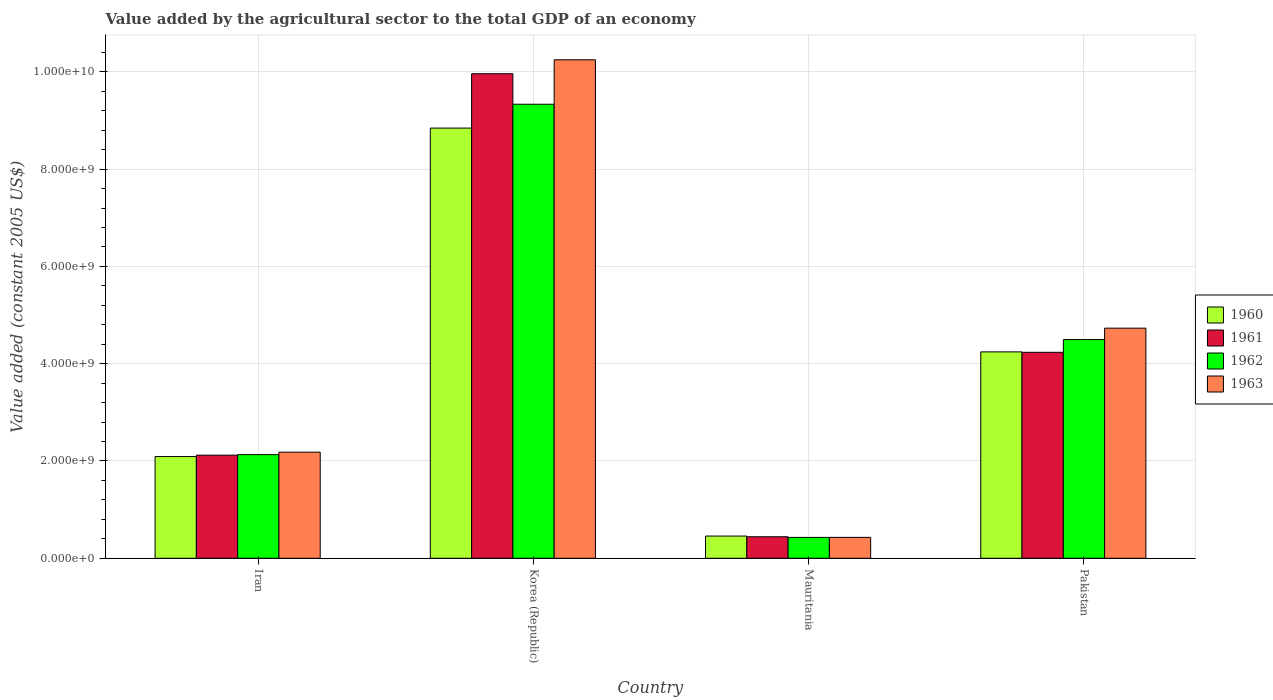How many different coloured bars are there?
Offer a very short reply. 4. Are the number of bars on each tick of the X-axis equal?
Provide a short and direct response. Yes. How many bars are there on the 3rd tick from the right?
Your answer should be compact. 4. What is the label of the 3rd group of bars from the left?
Your answer should be very brief. Mauritania. In how many cases, is the number of bars for a given country not equal to the number of legend labels?
Keep it short and to the point. 0. What is the value added by the agricultural sector in 1960 in Pakistan?
Make the answer very short. 4.24e+09. Across all countries, what is the maximum value added by the agricultural sector in 1960?
Your answer should be compact. 8.84e+09. Across all countries, what is the minimum value added by the agricultural sector in 1962?
Give a very brief answer. 4.29e+08. In which country was the value added by the agricultural sector in 1962 minimum?
Ensure brevity in your answer.  Mauritania. What is the total value added by the agricultural sector in 1963 in the graph?
Your answer should be very brief. 1.76e+1. What is the difference between the value added by the agricultural sector in 1963 in Iran and that in Pakistan?
Offer a very short reply. -2.55e+09. What is the difference between the value added by the agricultural sector in 1960 in Korea (Republic) and the value added by the agricultural sector in 1963 in Pakistan?
Make the answer very short. 4.11e+09. What is the average value added by the agricultural sector in 1962 per country?
Offer a terse response. 4.10e+09. What is the difference between the value added by the agricultural sector of/in 1960 and value added by the agricultural sector of/in 1961 in Mauritania?
Provide a short and direct response. 1.44e+07. In how many countries, is the value added by the agricultural sector in 1961 greater than 2400000000 US$?
Keep it short and to the point. 2. What is the ratio of the value added by the agricultural sector in 1963 in Iran to that in Pakistan?
Offer a terse response. 0.46. What is the difference between the highest and the second highest value added by the agricultural sector in 1961?
Your answer should be very brief. -7.84e+09. What is the difference between the highest and the lowest value added by the agricultural sector in 1963?
Your answer should be very brief. 9.82e+09. Is it the case that in every country, the sum of the value added by the agricultural sector in 1961 and value added by the agricultural sector in 1962 is greater than the sum of value added by the agricultural sector in 1960 and value added by the agricultural sector in 1963?
Make the answer very short. No. What does the 3rd bar from the left in Korea (Republic) represents?
Offer a very short reply. 1962. How many bars are there?
Keep it short and to the point. 16. What is the difference between two consecutive major ticks on the Y-axis?
Your response must be concise. 2.00e+09. Does the graph contain any zero values?
Your answer should be compact. No. Does the graph contain grids?
Ensure brevity in your answer.  Yes. Where does the legend appear in the graph?
Your answer should be compact. Center right. How are the legend labels stacked?
Your response must be concise. Vertical. What is the title of the graph?
Offer a terse response. Value added by the agricultural sector to the total GDP of an economy. Does "2010" appear as one of the legend labels in the graph?
Provide a succinct answer. No. What is the label or title of the Y-axis?
Offer a very short reply. Value added (constant 2005 US$). What is the Value added (constant 2005 US$) of 1960 in Iran?
Ensure brevity in your answer.  2.09e+09. What is the Value added (constant 2005 US$) in 1961 in Iran?
Give a very brief answer. 2.12e+09. What is the Value added (constant 2005 US$) of 1962 in Iran?
Offer a very short reply. 2.13e+09. What is the Value added (constant 2005 US$) in 1963 in Iran?
Keep it short and to the point. 2.18e+09. What is the Value added (constant 2005 US$) of 1960 in Korea (Republic)?
Offer a very short reply. 8.84e+09. What is the Value added (constant 2005 US$) in 1961 in Korea (Republic)?
Your response must be concise. 9.96e+09. What is the Value added (constant 2005 US$) of 1962 in Korea (Republic)?
Your answer should be very brief. 9.33e+09. What is the Value added (constant 2005 US$) in 1963 in Korea (Republic)?
Offer a terse response. 1.02e+1. What is the Value added (constant 2005 US$) of 1960 in Mauritania?
Your answer should be compact. 4.57e+08. What is the Value added (constant 2005 US$) in 1961 in Mauritania?
Provide a succinct answer. 4.42e+08. What is the Value added (constant 2005 US$) in 1962 in Mauritania?
Give a very brief answer. 4.29e+08. What is the Value added (constant 2005 US$) of 1963 in Mauritania?
Keep it short and to the point. 4.30e+08. What is the Value added (constant 2005 US$) of 1960 in Pakistan?
Offer a very short reply. 4.24e+09. What is the Value added (constant 2005 US$) in 1961 in Pakistan?
Make the answer very short. 4.23e+09. What is the Value added (constant 2005 US$) in 1962 in Pakistan?
Keep it short and to the point. 4.50e+09. What is the Value added (constant 2005 US$) in 1963 in Pakistan?
Offer a terse response. 4.73e+09. Across all countries, what is the maximum Value added (constant 2005 US$) in 1960?
Keep it short and to the point. 8.84e+09. Across all countries, what is the maximum Value added (constant 2005 US$) of 1961?
Your answer should be compact. 9.96e+09. Across all countries, what is the maximum Value added (constant 2005 US$) in 1962?
Your response must be concise. 9.33e+09. Across all countries, what is the maximum Value added (constant 2005 US$) in 1963?
Ensure brevity in your answer.  1.02e+1. Across all countries, what is the minimum Value added (constant 2005 US$) in 1960?
Your response must be concise. 4.57e+08. Across all countries, what is the minimum Value added (constant 2005 US$) in 1961?
Your answer should be very brief. 4.42e+08. Across all countries, what is the minimum Value added (constant 2005 US$) in 1962?
Your answer should be very brief. 4.29e+08. Across all countries, what is the minimum Value added (constant 2005 US$) in 1963?
Ensure brevity in your answer.  4.30e+08. What is the total Value added (constant 2005 US$) of 1960 in the graph?
Provide a succinct answer. 1.56e+1. What is the total Value added (constant 2005 US$) in 1961 in the graph?
Make the answer very short. 1.68e+1. What is the total Value added (constant 2005 US$) of 1962 in the graph?
Ensure brevity in your answer.  1.64e+1. What is the total Value added (constant 2005 US$) in 1963 in the graph?
Make the answer very short. 1.76e+1. What is the difference between the Value added (constant 2005 US$) in 1960 in Iran and that in Korea (Republic)?
Provide a short and direct response. -6.75e+09. What is the difference between the Value added (constant 2005 US$) of 1961 in Iran and that in Korea (Republic)?
Ensure brevity in your answer.  -7.84e+09. What is the difference between the Value added (constant 2005 US$) in 1962 in Iran and that in Korea (Republic)?
Give a very brief answer. -7.20e+09. What is the difference between the Value added (constant 2005 US$) of 1963 in Iran and that in Korea (Republic)?
Offer a very short reply. -8.07e+09. What is the difference between the Value added (constant 2005 US$) in 1960 in Iran and that in Mauritania?
Give a very brief answer. 1.63e+09. What is the difference between the Value added (constant 2005 US$) of 1961 in Iran and that in Mauritania?
Make the answer very short. 1.68e+09. What is the difference between the Value added (constant 2005 US$) in 1962 in Iran and that in Mauritania?
Your answer should be compact. 1.70e+09. What is the difference between the Value added (constant 2005 US$) of 1963 in Iran and that in Mauritania?
Your answer should be compact. 1.75e+09. What is the difference between the Value added (constant 2005 US$) in 1960 in Iran and that in Pakistan?
Give a very brief answer. -2.15e+09. What is the difference between the Value added (constant 2005 US$) in 1961 in Iran and that in Pakistan?
Your answer should be compact. -2.11e+09. What is the difference between the Value added (constant 2005 US$) of 1962 in Iran and that in Pakistan?
Offer a very short reply. -2.37e+09. What is the difference between the Value added (constant 2005 US$) in 1963 in Iran and that in Pakistan?
Ensure brevity in your answer.  -2.55e+09. What is the difference between the Value added (constant 2005 US$) in 1960 in Korea (Republic) and that in Mauritania?
Provide a short and direct response. 8.39e+09. What is the difference between the Value added (constant 2005 US$) of 1961 in Korea (Republic) and that in Mauritania?
Your answer should be very brief. 9.52e+09. What is the difference between the Value added (constant 2005 US$) of 1962 in Korea (Republic) and that in Mauritania?
Your answer should be very brief. 8.91e+09. What is the difference between the Value added (constant 2005 US$) of 1963 in Korea (Republic) and that in Mauritania?
Ensure brevity in your answer.  9.82e+09. What is the difference between the Value added (constant 2005 US$) in 1960 in Korea (Republic) and that in Pakistan?
Provide a succinct answer. 4.60e+09. What is the difference between the Value added (constant 2005 US$) in 1961 in Korea (Republic) and that in Pakistan?
Keep it short and to the point. 5.73e+09. What is the difference between the Value added (constant 2005 US$) in 1962 in Korea (Republic) and that in Pakistan?
Provide a short and direct response. 4.84e+09. What is the difference between the Value added (constant 2005 US$) of 1963 in Korea (Republic) and that in Pakistan?
Your response must be concise. 5.52e+09. What is the difference between the Value added (constant 2005 US$) of 1960 in Mauritania and that in Pakistan?
Your answer should be compact. -3.79e+09. What is the difference between the Value added (constant 2005 US$) of 1961 in Mauritania and that in Pakistan?
Your answer should be very brief. -3.79e+09. What is the difference between the Value added (constant 2005 US$) in 1962 in Mauritania and that in Pakistan?
Provide a short and direct response. -4.07e+09. What is the difference between the Value added (constant 2005 US$) in 1963 in Mauritania and that in Pakistan?
Make the answer very short. -4.30e+09. What is the difference between the Value added (constant 2005 US$) of 1960 in Iran and the Value added (constant 2005 US$) of 1961 in Korea (Republic)?
Offer a terse response. -7.87e+09. What is the difference between the Value added (constant 2005 US$) of 1960 in Iran and the Value added (constant 2005 US$) of 1962 in Korea (Republic)?
Provide a succinct answer. -7.24e+09. What is the difference between the Value added (constant 2005 US$) in 1960 in Iran and the Value added (constant 2005 US$) in 1963 in Korea (Republic)?
Your response must be concise. -8.16e+09. What is the difference between the Value added (constant 2005 US$) of 1961 in Iran and the Value added (constant 2005 US$) of 1962 in Korea (Republic)?
Ensure brevity in your answer.  -7.21e+09. What is the difference between the Value added (constant 2005 US$) of 1961 in Iran and the Value added (constant 2005 US$) of 1963 in Korea (Republic)?
Provide a succinct answer. -8.13e+09. What is the difference between the Value added (constant 2005 US$) in 1962 in Iran and the Value added (constant 2005 US$) in 1963 in Korea (Republic)?
Offer a very short reply. -8.12e+09. What is the difference between the Value added (constant 2005 US$) of 1960 in Iran and the Value added (constant 2005 US$) of 1961 in Mauritania?
Provide a succinct answer. 1.65e+09. What is the difference between the Value added (constant 2005 US$) of 1960 in Iran and the Value added (constant 2005 US$) of 1962 in Mauritania?
Keep it short and to the point. 1.66e+09. What is the difference between the Value added (constant 2005 US$) in 1960 in Iran and the Value added (constant 2005 US$) in 1963 in Mauritania?
Offer a very short reply. 1.66e+09. What is the difference between the Value added (constant 2005 US$) of 1961 in Iran and the Value added (constant 2005 US$) of 1962 in Mauritania?
Provide a succinct answer. 1.69e+09. What is the difference between the Value added (constant 2005 US$) of 1961 in Iran and the Value added (constant 2005 US$) of 1963 in Mauritania?
Your answer should be compact. 1.69e+09. What is the difference between the Value added (constant 2005 US$) in 1962 in Iran and the Value added (constant 2005 US$) in 1963 in Mauritania?
Give a very brief answer. 1.70e+09. What is the difference between the Value added (constant 2005 US$) of 1960 in Iran and the Value added (constant 2005 US$) of 1961 in Pakistan?
Your response must be concise. -2.14e+09. What is the difference between the Value added (constant 2005 US$) of 1960 in Iran and the Value added (constant 2005 US$) of 1962 in Pakistan?
Your response must be concise. -2.40e+09. What is the difference between the Value added (constant 2005 US$) in 1960 in Iran and the Value added (constant 2005 US$) in 1963 in Pakistan?
Offer a terse response. -2.64e+09. What is the difference between the Value added (constant 2005 US$) of 1961 in Iran and the Value added (constant 2005 US$) of 1962 in Pakistan?
Give a very brief answer. -2.38e+09. What is the difference between the Value added (constant 2005 US$) of 1961 in Iran and the Value added (constant 2005 US$) of 1963 in Pakistan?
Your answer should be very brief. -2.61e+09. What is the difference between the Value added (constant 2005 US$) of 1962 in Iran and the Value added (constant 2005 US$) of 1963 in Pakistan?
Make the answer very short. -2.60e+09. What is the difference between the Value added (constant 2005 US$) of 1960 in Korea (Republic) and the Value added (constant 2005 US$) of 1961 in Mauritania?
Ensure brevity in your answer.  8.40e+09. What is the difference between the Value added (constant 2005 US$) in 1960 in Korea (Republic) and the Value added (constant 2005 US$) in 1962 in Mauritania?
Give a very brief answer. 8.41e+09. What is the difference between the Value added (constant 2005 US$) of 1960 in Korea (Republic) and the Value added (constant 2005 US$) of 1963 in Mauritania?
Give a very brief answer. 8.41e+09. What is the difference between the Value added (constant 2005 US$) of 1961 in Korea (Republic) and the Value added (constant 2005 US$) of 1962 in Mauritania?
Provide a short and direct response. 9.53e+09. What is the difference between the Value added (constant 2005 US$) in 1961 in Korea (Republic) and the Value added (constant 2005 US$) in 1963 in Mauritania?
Offer a very short reply. 9.53e+09. What is the difference between the Value added (constant 2005 US$) in 1962 in Korea (Republic) and the Value added (constant 2005 US$) in 1963 in Mauritania?
Your answer should be compact. 8.90e+09. What is the difference between the Value added (constant 2005 US$) of 1960 in Korea (Republic) and the Value added (constant 2005 US$) of 1961 in Pakistan?
Offer a very short reply. 4.61e+09. What is the difference between the Value added (constant 2005 US$) of 1960 in Korea (Republic) and the Value added (constant 2005 US$) of 1962 in Pakistan?
Keep it short and to the point. 4.35e+09. What is the difference between the Value added (constant 2005 US$) of 1960 in Korea (Republic) and the Value added (constant 2005 US$) of 1963 in Pakistan?
Your answer should be very brief. 4.11e+09. What is the difference between the Value added (constant 2005 US$) in 1961 in Korea (Republic) and the Value added (constant 2005 US$) in 1962 in Pakistan?
Make the answer very short. 5.46e+09. What is the difference between the Value added (constant 2005 US$) of 1961 in Korea (Republic) and the Value added (constant 2005 US$) of 1963 in Pakistan?
Provide a succinct answer. 5.23e+09. What is the difference between the Value added (constant 2005 US$) of 1962 in Korea (Republic) and the Value added (constant 2005 US$) of 1963 in Pakistan?
Give a very brief answer. 4.60e+09. What is the difference between the Value added (constant 2005 US$) of 1960 in Mauritania and the Value added (constant 2005 US$) of 1961 in Pakistan?
Your answer should be compact. -3.78e+09. What is the difference between the Value added (constant 2005 US$) in 1960 in Mauritania and the Value added (constant 2005 US$) in 1962 in Pakistan?
Your response must be concise. -4.04e+09. What is the difference between the Value added (constant 2005 US$) of 1960 in Mauritania and the Value added (constant 2005 US$) of 1963 in Pakistan?
Keep it short and to the point. -4.27e+09. What is the difference between the Value added (constant 2005 US$) in 1961 in Mauritania and the Value added (constant 2005 US$) in 1962 in Pakistan?
Your response must be concise. -4.05e+09. What is the difference between the Value added (constant 2005 US$) of 1961 in Mauritania and the Value added (constant 2005 US$) of 1963 in Pakistan?
Give a very brief answer. -4.29e+09. What is the difference between the Value added (constant 2005 US$) in 1962 in Mauritania and the Value added (constant 2005 US$) in 1963 in Pakistan?
Ensure brevity in your answer.  -4.30e+09. What is the average Value added (constant 2005 US$) of 1960 per country?
Offer a terse response. 3.91e+09. What is the average Value added (constant 2005 US$) in 1961 per country?
Your answer should be very brief. 4.19e+09. What is the average Value added (constant 2005 US$) of 1962 per country?
Your response must be concise. 4.10e+09. What is the average Value added (constant 2005 US$) of 1963 per country?
Provide a succinct answer. 4.40e+09. What is the difference between the Value added (constant 2005 US$) of 1960 and Value added (constant 2005 US$) of 1961 in Iran?
Give a very brief answer. -2.84e+07. What is the difference between the Value added (constant 2005 US$) in 1960 and Value added (constant 2005 US$) in 1962 in Iran?
Your answer should be compact. -3.89e+07. What is the difference between the Value added (constant 2005 US$) of 1960 and Value added (constant 2005 US$) of 1963 in Iran?
Your answer should be compact. -9.02e+07. What is the difference between the Value added (constant 2005 US$) in 1961 and Value added (constant 2005 US$) in 1962 in Iran?
Your answer should be compact. -1.05e+07. What is the difference between the Value added (constant 2005 US$) of 1961 and Value added (constant 2005 US$) of 1963 in Iran?
Provide a short and direct response. -6.18e+07. What is the difference between the Value added (constant 2005 US$) in 1962 and Value added (constant 2005 US$) in 1963 in Iran?
Offer a very short reply. -5.13e+07. What is the difference between the Value added (constant 2005 US$) in 1960 and Value added (constant 2005 US$) in 1961 in Korea (Republic)?
Your answer should be compact. -1.12e+09. What is the difference between the Value added (constant 2005 US$) in 1960 and Value added (constant 2005 US$) in 1962 in Korea (Republic)?
Ensure brevity in your answer.  -4.90e+08. What is the difference between the Value added (constant 2005 US$) of 1960 and Value added (constant 2005 US$) of 1963 in Korea (Republic)?
Make the answer very short. -1.40e+09. What is the difference between the Value added (constant 2005 US$) in 1961 and Value added (constant 2005 US$) in 1962 in Korea (Republic)?
Provide a succinct answer. 6.27e+08. What is the difference between the Value added (constant 2005 US$) of 1961 and Value added (constant 2005 US$) of 1963 in Korea (Republic)?
Provide a succinct answer. -2.87e+08. What is the difference between the Value added (constant 2005 US$) of 1962 and Value added (constant 2005 US$) of 1963 in Korea (Republic)?
Keep it short and to the point. -9.14e+08. What is the difference between the Value added (constant 2005 US$) in 1960 and Value added (constant 2005 US$) in 1961 in Mauritania?
Keep it short and to the point. 1.44e+07. What is the difference between the Value added (constant 2005 US$) in 1960 and Value added (constant 2005 US$) in 1962 in Mauritania?
Offer a very short reply. 2.75e+07. What is the difference between the Value added (constant 2005 US$) of 1960 and Value added (constant 2005 US$) of 1963 in Mauritania?
Offer a very short reply. 2.68e+07. What is the difference between the Value added (constant 2005 US$) in 1961 and Value added (constant 2005 US$) in 1962 in Mauritania?
Your response must be concise. 1.31e+07. What is the difference between the Value added (constant 2005 US$) of 1961 and Value added (constant 2005 US$) of 1963 in Mauritania?
Provide a succinct answer. 1.24e+07. What is the difference between the Value added (constant 2005 US$) in 1962 and Value added (constant 2005 US$) in 1963 in Mauritania?
Ensure brevity in your answer.  -7.06e+05. What is the difference between the Value added (constant 2005 US$) in 1960 and Value added (constant 2005 US$) in 1961 in Pakistan?
Give a very brief answer. 8.56e+06. What is the difference between the Value added (constant 2005 US$) of 1960 and Value added (constant 2005 US$) of 1962 in Pakistan?
Offer a very short reply. -2.53e+08. What is the difference between the Value added (constant 2005 US$) in 1960 and Value added (constant 2005 US$) in 1963 in Pakistan?
Your answer should be compact. -4.87e+08. What is the difference between the Value added (constant 2005 US$) of 1961 and Value added (constant 2005 US$) of 1962 in Pakistan?
Your answer should be very brief. -2.62e+08. What is the difference between the Value added (constant 2005 US$) of 1961 and Value added (constant 2005 US$) of 1963 in Pakistan?
Make the answer very short. -4.96e+08. What is the difference between the Value added (constant 2005 US$) of 1962 and Value added (constant 2005 US$) of 1963 in Pakistan?
Offer a very short reply. -2.34e+08. What is the ratio of the Value added (constant 2005 US$) of 1960 in Iran to that in Korea (Republic)?
Your answer should be compact. 0.24. What is the ratio of the Value added (constant 2005 US$) in 1961 in Iran to that in Korea (Republic)?
Make the answer very short. 0.21. What is the ratio of the Value added (constant 2005 US$) of 1962 in Iran to that in Korea (Republic)?
Offer a terse response. 0.23. What is the ratio of the Value added (constant 2005 US$) of 1963 in Iran to that in Korea (Republic)?
Offer a very short reply. 0.21. What is the ratio of the Value added (constant 2005 US$) in 1960 in Iran to that in Mauritania?
Ensure brevity in your answer.  4.58. What is the ratio of the Value added (constant 2005 US$) of 1961 in Iran to that in Mauritania?
Ensure brevity in your answer.  4.79. What is the ratio of the Value added (constant 2005 US$) of 1962 in Iran to that in Mauritania?
Give a very brief answer. 4.96. What is the ratio of the Value added (constant 2005 US$) of 1963 in Iran to that in Mauritania?
Ensure brevity in your answer.  5.07. What is the ratio of the Value added (constant 2005 US$) in 1960 in Iran to that in Pakistan?
Offer a very short reply. 0.49. What is the ratio of the Value added (constant 2005 US$) in 1961 in Iran to that in Pakistan?
Your answer should be compact. 0.5. What is the ratio of the Value added (constant 2005 US$) in 1962 in Iran to that in Pakistan?
Offer a terse response. 0.47. What is the ratio of the Value added (constant 2005 US$) in 1963 in Iran to that in Pakistan?
Ensure brevity in your answer.  0.46. What is the ratio of the Value added (constant 2005 US$) of 1960 in Korea (Republic) to that in Mauritania?
Give a very brief answer. 19.37. What is the ratio of the Value added (constant 2005 US$) of 1961 in Korea (Republic) to that in Mauritania?
Offer a terse response. 22.52. What is the ratio of the Value added (constant 2005 US$) in 1962 in Korea (Republic) to that in Mauritania?
Provide a succinct answer. 21.75. What is the ratio of the Value added (constant 2005 US$) of 1963 in Korea (Republic) to that in Mauritania?
Make the answer very short. 23.84. What is the ratio of the Value added (constant 2005 US$) in 1960 in Korea (Republic) to that in Pakistan?
Keep it short and to the point. 2.08. What is the ratio of the Value added (constant 2005 US$) of 1961 in Korea (Republic) to that in Pakistan?
Give a very brief answer. 2.35. What is the ratio of the Value added (constant 2005 US$) in 1962 in Korea (Republic) to that in Pakistan?
Offer a very short reply. 2.08. What is the ratio of the Value added (constant 2005 US$) in 1963 in Korea (Republic) to that in Pakistan?
Your answer should be compact. 2.17. What is the ratio of the Value added (constant 2005 US$) of 1960 in Mauritania to that in Pakistan?
Your answer should be compact. 0.11. What is the ratio of the Value added (constant 2005 US$) in 1961 in Mauritania to that in Pakistan?
Your answer should be compact. 0.1. What is the ratio of the Value added (constant 2005 US$) of 1962 in Mauritania to that in Pakistan?
Your answer should be compact. 0.1. What is the ratio of the Value added (constant 2005 US$) in 1963 in Mauritania to that in Pakistan?
Give a very brief answer. 0.09. What is the difference between the highest and the second highest Value added (constant 2005 US$) in 1960?
Your answer should be compact. 4.60e+09. What is the difference between the highest and the second highest Value added (constant 2005 US$) of 1961?
Offer a terse response. 5.73e+09. What is the difference between the highest and the second highest Value added (constant 2005 US$) in 1962?
Offer a terse response. 4.84e+09. What is the difference between the highest and the second highest Value added (constant 2005 US$) in 1963?
Provide a succinct answer. 5.52e+09. What is the difference between the highest and the lowest Value added (constant 2005 US$) of 1960?
Your answer should be compact. 8.39e+09. What is the difference between the highest and the lowest Value added (constant 2005 US$) in 1961?
Offer a very short reply. 9.52e+09. What is the difference between the highest and the lowest Value added (constant 2005 US$) of 1962?
Your answer should be very brief. 8.91e+09. What is the difference between the highest and the lowest Value added (constant 2005 US$) in 1963?
Offer a terse response. 9.82e+09. 